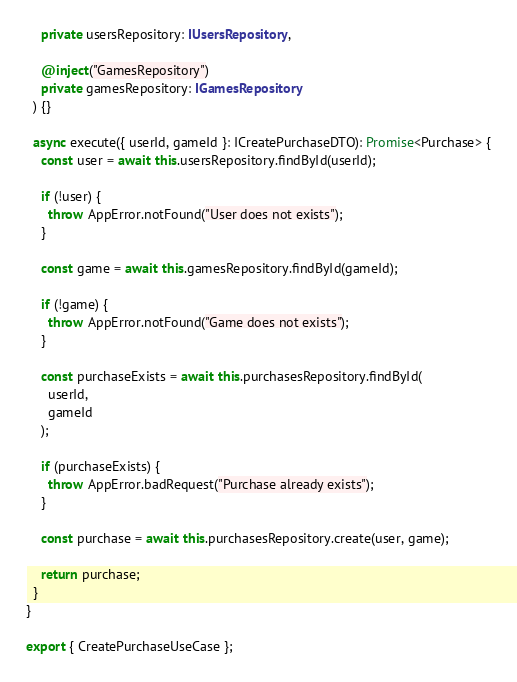<code> <loc_0><loc_0><loc_500><loc_500><_TypeScript_>    private usersRepository: IUsersRepository,

    @inject("GamesRepository")
    private gamesRepository: IGamesRepository
  ) {}

  async execute({ userId, gameId }: ICreatePurchaseDTO): Promise<Purchase> {
    const user = await this.usersRepository.findById(userId);

    if (!user) {
      throw AppError.notFound("User does not exists");
    }

    const game = await this.gamesRepository.findById(gameId);

    if (!game) {
      throw AppError.notFound("Game does not exists");
    }

    const purchaseExists = await this.purchasesRepository.findById(
      userId,
      gameId
    );

    if (purchaseExists) {
      throw AppError.badRequest("Purchase already exists");
    }

    const purchase = await this.purchasesRepository.create(user, game);

    return purchase;
  }
}

export { CreatePurchaseUseCase };
</code> 